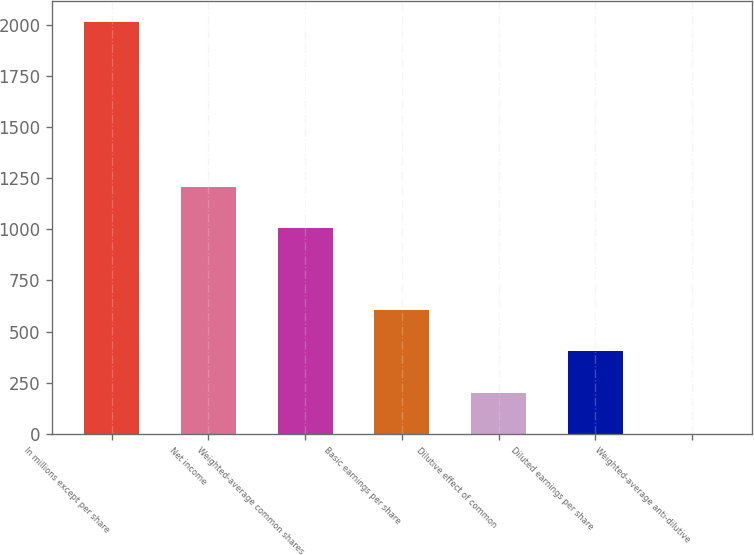Convert chart. <chart><loc_0><loc_0><loc_500><loc_500><bar_chart><fcel>In millions except per share<fcel>Net income<fcel>Weighted-average common shares<fcel>Basic earnings per share<fcel>Dilutive effect of common<fcel>Diluted earnings per share<fcel>Weighted-average anti-dilutive<nl><fcel>2014<fcel>1208.68<fcel>1007.35<fcel>604.69<fcel>202.03<fcel>403.36<fcel>0.7<nl></chart> 